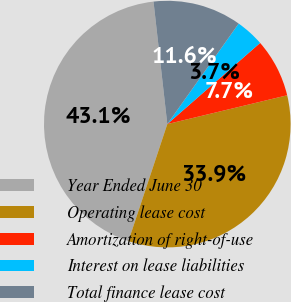<chart> <loc_0><loc_0><loc_500><loc_500><pie_chart><fcel>Year Ended June 30<fcel>Operating lease cost<fcel>Amortization of right-of-use<fcel>Interest on lease liabilities<fcel>Total finance lease cost<nl><fcel>43.11%<fcel>33.86%<fcel>7.68%<fcel>3.74%<fcel>11.61%<nl></chart> 